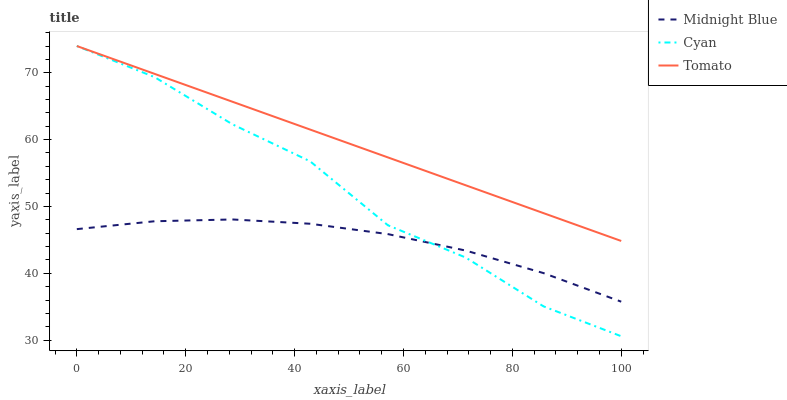Does Midnight Blue have the minimum area under the curve?
Answer yes or no. Yes. Does Tomato have the maximum area under the curve?
Answer yes or no. Yes. Does Cyan have the minimum area under the curve?
Answer yes or no. No. Does Cyan have the maximum area under the curve?
Answer yes or no. No. Is Tomato the smoothest?
Answer yes or no. Yes. Is Cyan the roughest?
Answer yes or no. Yes. Is Midnight Blue the smoothest?
Answer yes or no. No. Is Midnight Blue the roughest?
Answer yes or no. No. Does Cyan have the lowest value?
Answer yes or no. Yes. Does Midnight Blue have the lowest value?
Answer yes or no. No. Does Cyan have the highest value?
Answer yes or no. Yes. Does Midnight Blue have the highest value?
Answer yes or no. No. Is Midnight Blue less than Tomato?
Answer yes or no. Yes. Is Tomato greater than Midnight Blue?
Answer yes or no. Yes. Does Cyan intersect Tomato?
Answer yes or no. Yes. Is Cyan less than Tomato?
Answer yes or no. No. Is Cyan greater than Tomato?
Answer yes or no. No. Does Midnight Blue intersect Tomato?
Answer yes or no. No. 